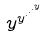<formula> <loc_0><loc_0><loc_500><loc_500>y ^ { y ^ { \cdot ^ { \cdot ^ { \cdot ^ { y } } } } }</formula> 